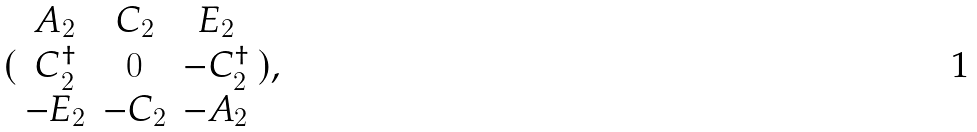<formula> <loc_0><loc_0><loc_500><loc_500>( \begin{array} { c c c } A _ { 2 } & C _ { 2 } & E _ { 2 } \\ C _ { 2 } ^ { \dagger } & 0 & - C _ { 2 } ^ { \dagger } \\ - E _ { 2 } & - C _ { 2 } & - A _ { 2 } \end{array} ) ,</formula> 